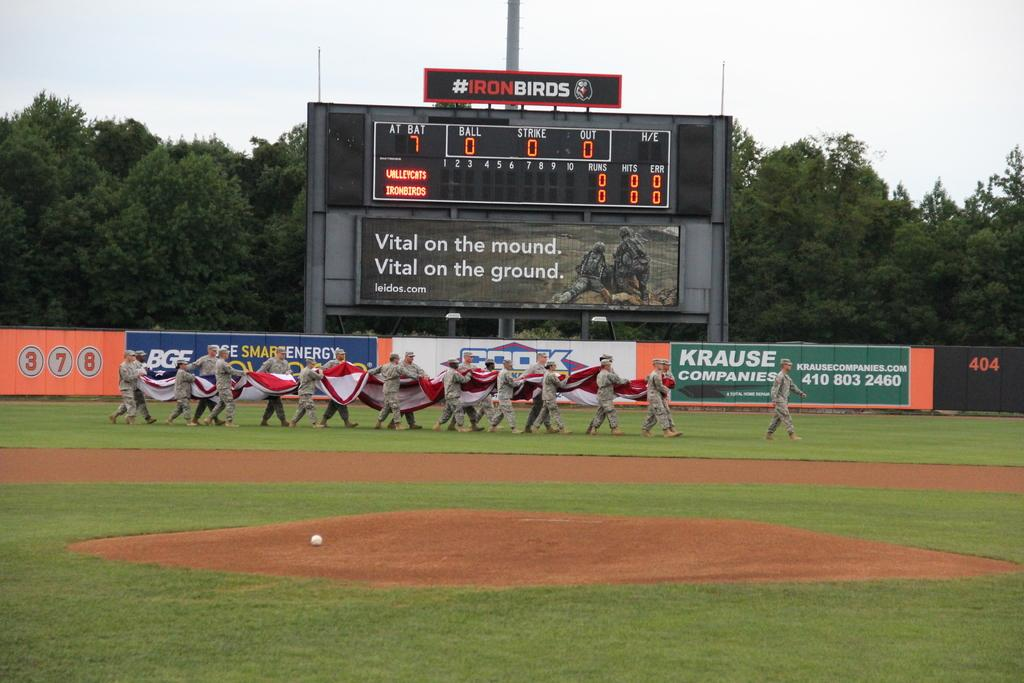<image>
Relay a brief, clear account of the picture shown. All the scores read zero on the scoreboard of this baseball park. 